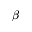<formula> <loc_0><loc_0><loc_500><loc_500>\beta</formula> 